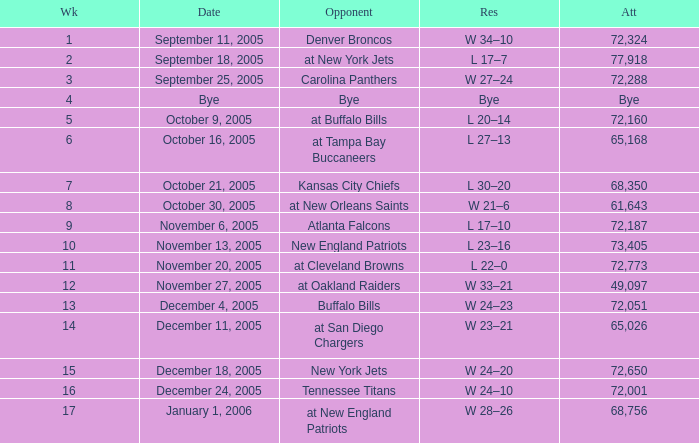In what Week was the Attendance 49,097? 12.0. 